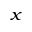<formula> <loc_0><loc_0><loc_500><loc_500>_ { x }</formula> 